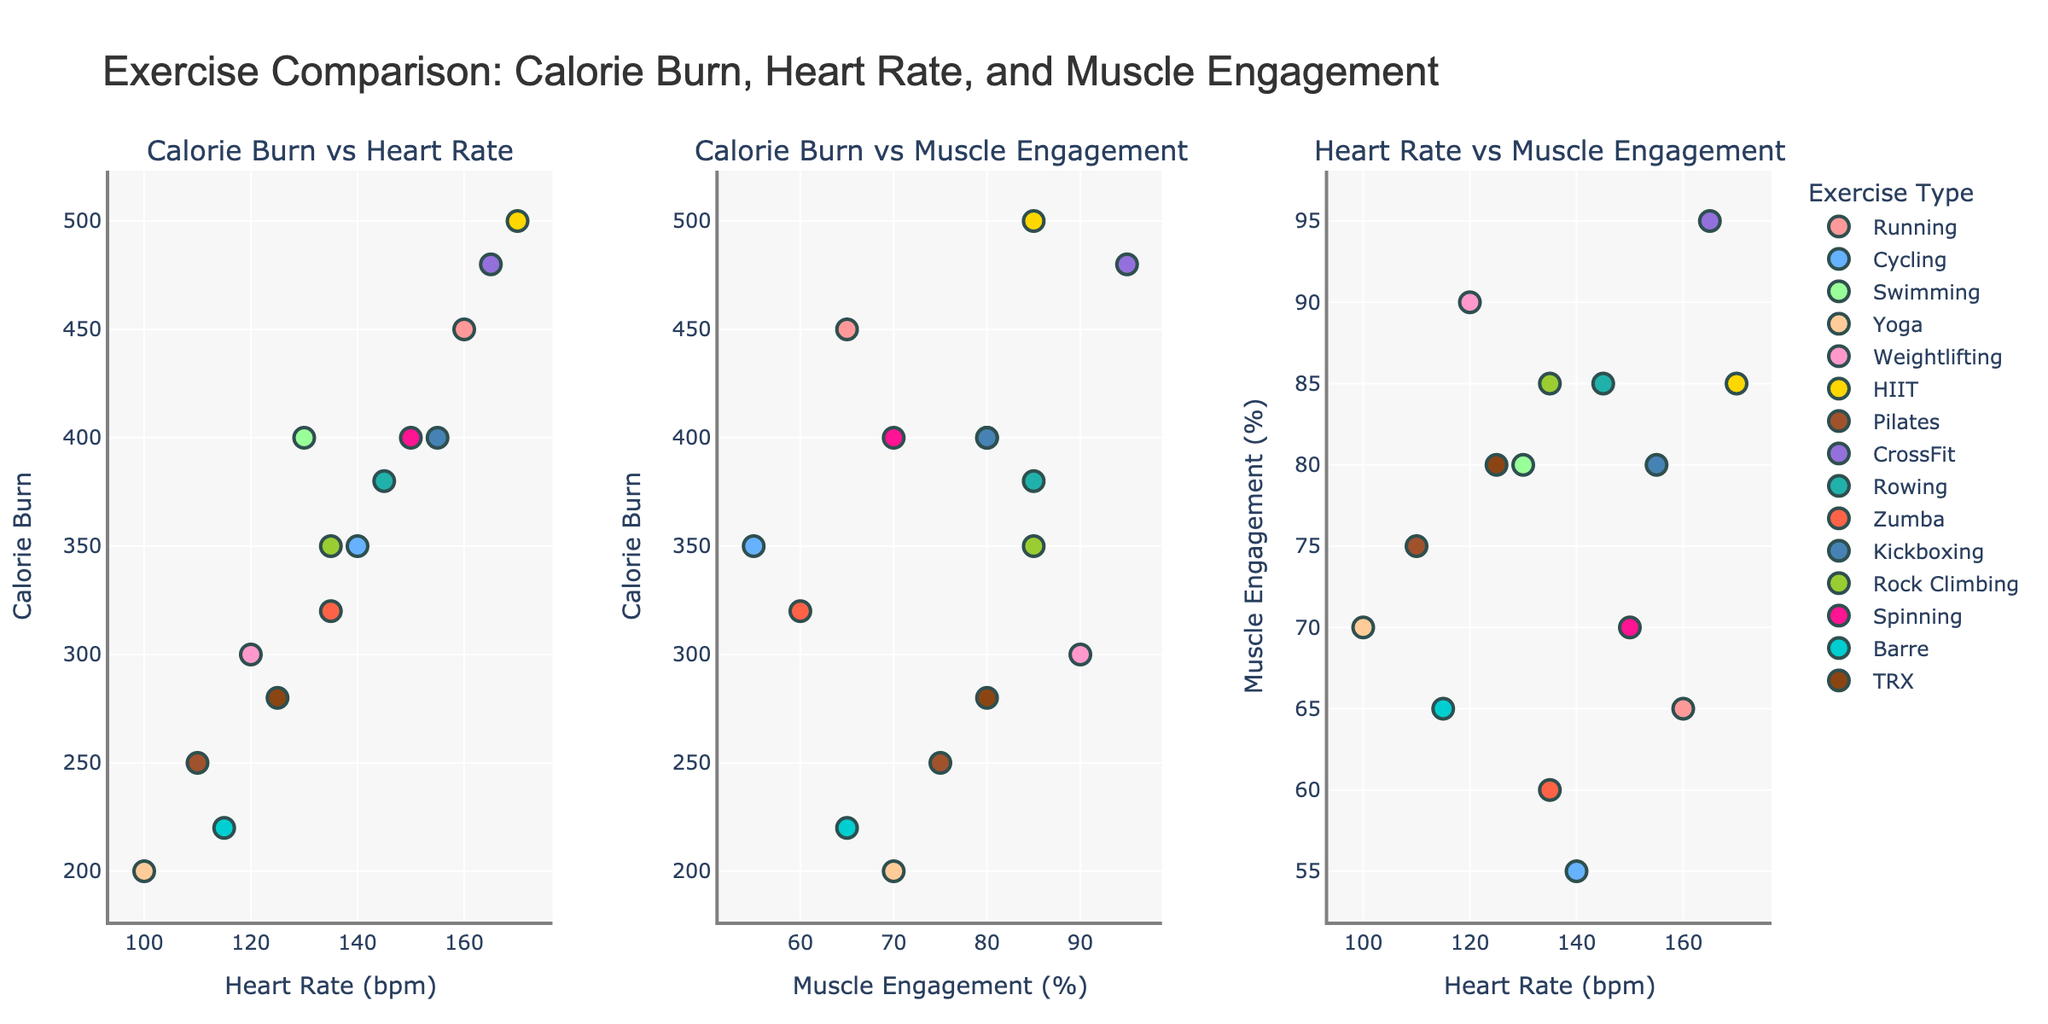What is the title of the plot? The title can be found at the top center of the figure, stating what the figure is about. It reads "Exercise Comparison: Calorie Burn, Heart Rate, and Muscle Engagement"
Answer: Exercise Comparison: Calorie Burn, Heart Rate, and Muscle Engagement Which exercise type burns the most calories? By looking at the highest y-value in the first and second subplots, we see that HIIT has the highest calorie burn, marked at 500 calories.
Answer: HIIT What is the range of heart rates observed in the exercises? The x-axis in the first and third subplots shows heart rates. The minimum heart rate is around 100 bpm and the maximum is around 170 bpm.
Answer: 100 - 170 bpm Which exercise has the highest muscle engagement and what is that value? In the second and third subplots, the highest y-value or x-value for muscle engagement is 95%, which corresponds to CrossFit.
Answer: CrossFit, 95% Which types of exercises have a heart rate greater than 140 bpm? From the first and third subplots, identify exercises with heart rates above 140 bpm. These include Running, Cycling, HIIT, Spinning, and CrossFit.
Answer: Running, Cycling, HIIT, Spinning, CrossFit What is the relationship between calorie burn and heart rate for exercises like Running and Yoga? In the first subplot, compare the points for Running and Yoga. Running has a higher calorie burn and heart rate (450 and 160), while Yoga has lower values for both (200 and 100).
Answer: Running has higher values than Yoga for both metrics Which exercise appears most efficient in terms of calorie burn per unit of muscle engagement? Efficiency can be thought of as calorie burn divided by muscle engagement. The highest calorie burn is 500 for HIIT with 85% muscle engagement, giving approximately 5.88 calories per percent. CrossFit also has high efficiency with 480 calories and 95%.
Answer: HIIT Does Zumba engage more muscle compared to Running? Compare the muscle engagement values in the second and third subplots. Zumba has 60% while Running has 65%.
Answer: No, Running engages more What is the average muscle engagement for weightlifting, HIIT, and TRX? Sum the muscle engagement percentages for Weightlifting (90), HIIT (85), and TRX (80) and divide by 3 to find the average. The calculation is (90 + 85 + 80) / 3 = 85%.
Answer: 85% Compare the calorie burn of Yoga and Barre, which one burns more? In the first and second subplots, the y-values for Yoga and Barre are 200 and 220 calories, respectively. Barre burns slightly more calories than Yoga.
Answer: Barre 